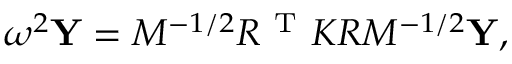<formula> <loc_0><loc_0><loc_500><loc_500>\omega ^ { 2 } Y = M ^ { - 1 / 2 } R ^ { T } K R M ^ { - 1 / 2 } Y ,</formula> 